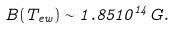Convert formula to latex. <formula><loc_0><loc_0><loc_500><loc_500>B ( T _ { e w } ) \sim 1 . 8 5 1 0 ^ { 1 4 } G .</formula> 